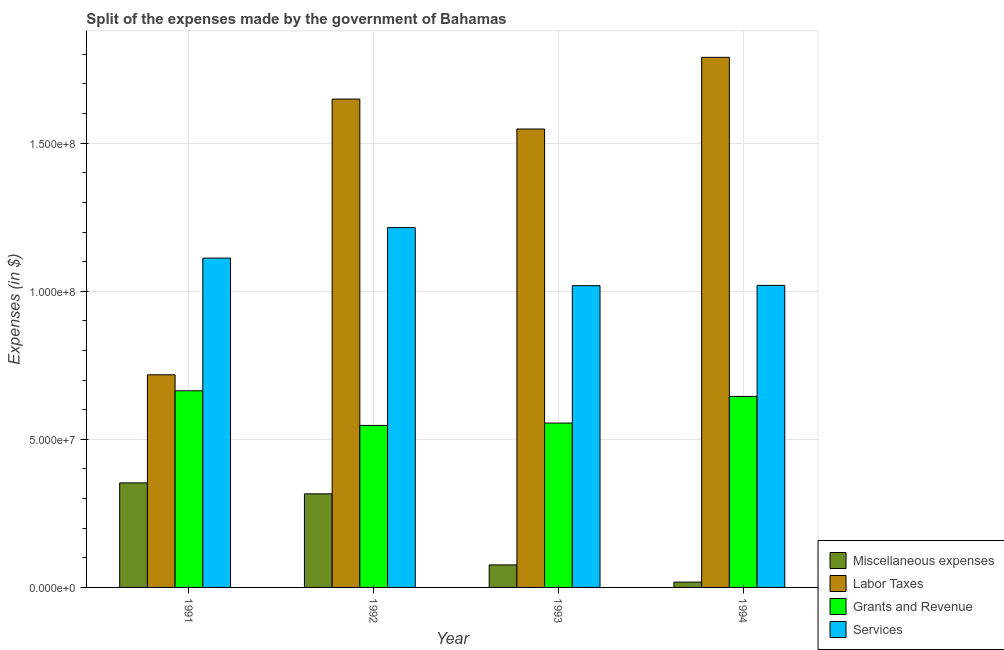How many different coloured bars are there?
Offer a terse response. 4. How many groups of bars are there?
Make the answer very short. 4. Are the number of bars on each tick of the X-axis equal?
Provide a short and direct response. Yes. What is the label of the 1st group of bars from the left?
Make the answer very short. 1991. What is the amount spent on labor taxes in 1991?
Offer a very short reply. 7.18e+07. Across all years, what is the maximum amount spent on miscellaneous expenses?
Your answer should be very brief. 3.53e+07. Across all years, what is the minimum amount spent on miscellaneous expenses?
Ensure brevity in your answer.  1.80e+06. In which year was the amount spent on labor taxes minimum?
Provide a succinct answer. 1991. What is the total amount spent on grants and revenue in the graph?
Offer a terse response. 2.41e+08. What is the difference between the amount spent on labor taxes in 1991 and that in 1994?
Offer a very short reply. -1.07e+08. What is the difference between the amount spent on services in 1993 and the amount spent on labor taxes in 1991?
Provide a short and direct response. -9.30e+06. What is the average amount spent on services per year?
Ensure brevity in your answer.  1.09e+08. In how many years, is the amount spent on grants and revenue greater than 40000000 $?
Keep it short and to the point. 4. What is the ratio of the amount spent on miscellaneous expenses in 1992 to that in 1994?
Give a very brief answer. 17.56. Is the difference between the amount spent on labor taxes in 1992 and 1994 greater than the difference between the amount spent on services in 1992 and 1994?
Keep it short and to the point. No. What is the difference between the highest and the second highest amount spent on grants and revenue?
Your answer should be very brief. 1.90e+06. What is the difference between the highest and the lowest amount spent on labor taxes?
Make the answer very short. 1.07e+08. Is the sum of the amount spent on grants and revenue in 1991 and 1994 greater than the maximum amount spent on services across all years?
Keep it short and to the point. Yes. Is it the case that in every year, the sum of the amount spent on labor taxes and amount spent on miscellaneous expenses is greater than the sum of amount spent on services and amount spent on grants and revenue?
Make the answer very short. No. What does the 4th bar from the left in 1992 represents?
Your response must be concise. Services. What does the 2nd bar from the right in 1991 represents?
Provide a short and direct response. Grants and Revenue. How many years are there in the graph?
Offer a very short reply. 4. What is the difference between two consecutive major ticks on the Y-axis?
Offer a very short reply. 5.00e+07. Does the graph contain grids?
Ensure brevity in your answer.  Yes. Where does the legend appear in the graph?
Your answer should be very brief. Bottom right. How are the legend labels stacked?
Your answer should be compact. Vertical. What is the title of the graph?
Make the answer very short. Split of the expenses made by the government of Bahamas. Does "UNPBF" appear as one of the legend labels in the graph?
Provide a succinct answer. No. What is the label or title of the X-axis?
Your answer should be compact. Year. What is the label or title of the Y-axis?
Your response must be concise. Expenses (in $). What is the Expenses (in $) in Miscellaneous expenses in 1991?
Your response must be concise. 3.53e+07. What is the Expenses (in $) in Labor Taxes in 1991?
Ensure brevity in your answer.  7.18e+07. What is the Expenses (in $) of Grants and Revenue in 1991?
Offer a terse response. 6.64e+07. What is the Expenses (in $) in Services in 1991?
Your response must be concise. 1.11e+08. What is the Expenses (in $) in Miscellaneous expenses in 1992?
Offer a terse response. 3.16e+07. What is the Expenses (in $) in Labor Taxes in 1992?
Offer a very short reply. 1.65e+08. What is the Expenses (in $) of Grants and Revenue in 1992?
Your response must be concise. 5.47e+07. What is the Expenses (in $) in Services in 1992?
Your answer should be very brief. 1.22e+08. What is the Expenses (in $) of Miscellaneous expenses in 1993?
Provide a succinct answer. 7.60e+06. What is the Expenses (in $) of Labor Taxes in 1993?
Provide a short and direct response. 1.55e+08. What is the Expenses (in $) of Grants and Revenue in 1993?
Offer a terse response. 5.55e+07. What is the Expenses (in $) in Services in 1993?
Ensure brevity in your answer.  1.02e+08. What is the Expenses (in $) in Miscellaneous expenses in 1994?
Offer a very short reply. 1.80e+06. What is the Expenses (in $) of Labor Taxes in 1994?
Your response must be concise. 1.79e+08. What is the Expenses (in $) in Grants and Revenue in 1994?
Ensure brevity in your answer.  6.45e+07. What is the Expenses (in $) of Services in 1994?
Ensure brevity in your answer.  1.02e+08. Across all years, what is the maximum Expenses (in $) in Miscellaneous expenses?
Keep it short and to the point. 3.53e+07. Across all years, what is the maximum Expenses (in $) in Labor Taxes?
Give a very brief answer. 1.79e+08. Across all years, what is the maximum Expenses (in $) in Grants and Revenue?
Give a very brief answer. 6.64e+07. Across all years, what is the maximum Expenses (in $) of Services?
Offer a very short reply. 1.22e+08. Across all years, what is the minimum Expenses (in $) in Miscellaneous expenses?
Offer a terse response. 1.80e+06. Across all years, what is the minimum Expenses (in $) in Labor Taxes?
Your response must be concise. 7.18e+07. Across all years, what is the minimum Expenses (in $) of Grants and Revenue?
Your answer should be very brief. 5.47e+07. Across all years, what is the minimum Expenses (in $) of Services?
Your response must be concise. 1.02e+08. What is the total Expenses (in $) in Miscellaneous expenses in the graph?
Your answer should be compact. 7.63e+07. What is the total Expenses (in $) of Labor Taxes in the graph?
Make the answer very short. 5.70e+08. What is the total Expenses (in $) in Grants and Revenue in the graph?
Make the answer very short. 2.41e+08. What is the total Expenses (in $) of Services in the graph?
Provide a short and direct response. 4.37e+08. What is the difference between the Expenses (in $) of Miscellaneous expenses in 1991 and that in 1992?
Your response must be concise. 3.70e+06. What is the difference between the Expenses (in $) of Labor Taxes in 1991 and that in 1992?
Your answer should be compact. -9.31e+07. What is the difference between the Expenses (in $) of Grants and Revenue in 1991 and that in 1992?
Your answer should be compact. 1.17e+07. What is the difference between the Expenses (in $) in Services in 1991 and that in 1992?
Make the answer very short. -1.03e+07. What is the difference between the Expenses (in $) of Miscellaneous expenses in 1991 and that in 1993?
Make the answer very short. 2.77e+07. What is the difference between the Expenses (in $) in Labor Taxes in 1991 and that in 1993?
Provide a succinct answer. -8.30e+07. What is the difference between the Expenses (in $) of Grants and Revenue in 1991 and that in 1993?
Provide a short and direct response. 1.09e+07. What is the difference between the Expenses (in $) in Services in 1991 and that in 1993?
Keep it short and to the point. 9.30e+06. What is the difference between the Expenses (in $) in Miscellaneous expenses in 1991 and that in 1994?
Give a very brief answer. 3.35e+07. What is the difference between the Expenses (in $) of Labor Taxes in 1991 and that in 1994?
Offer a very short reply. -1.07e+08. What is the difference between the Expenses (in $) of Grants and Revenue in 1991 and that in 1994?
Your response must be concise. 1.90e+06. What is the difference between the Expenses (in $) of Services in 1991 and that in 1994?
Ensure brevity in your answer.  9.20e+06. What is the difference between the Expenses (in $) of Miscellaneous expenses in 1992 and that in 1993?
Your answer should be compact. 2.40e+07. What is the difference between the Expenses (in $) of Labor Taxes in 1992 and that in 1993?
Ensure brevity in your answer.  1.01e+07. What is the difference between the Expenses (in $) in Grants and Revenue in 1992 and that in 1993?
Your response must be concise. -8.00e+05. What is the difference between the Expenses (in $) in Services in 1992 and that in 1993?
Provide a short and direct response. 1.96e+07. What is the difference between the Expenses (in $) of Miscellaneous expenses in 1992 and that in 1994?
Your answer should be compact. 2.98e+07. What is the difference between the Expenses (in $) in Labor Taxes in 1992 and that in 1994?
Your answer should be compact. -1.41e+07. What is the difference between the Expenses (in $) of Grants and Revenue in 1992 and that in 1994?
Offer a terse response. -9.80e+06. What is the difference between the Expenses (in $) in Services in 1992 and that in 1994?
Make the answer very short. 1.95e+07. What is the difference between the Expenses (in $) in Miscellaneous expenses in 1993 and that in 1994?
Your response must be concise. 5.80e+06. What is the difference between the Expenses (in $) in Labor Taxes in 1993 and that in 1994?
Provide a short and direct response. -2.42e+07. What is the difference between the Expenses (in $) in Grants and Revenue in 1993 and that in 1994?
Provide a succinct answer. -9.00e+06. What is the difference between the Expenses (in $) of Services in 1993 and that in 1994?
Provide a succinct answer. -1.00e+05. What is the difference between the Expenses (in $) of Miscellaneous expenses in 1991 and the Expenses (in $) of Labor Taxes in 1992?
Offer a very short reply. -1.30e+08. What is the difference between the Expenses (in $) of Miscellaneous expenses in 1991 and the Expenses (in $) of Grants and Revenue in 1992?
Provide a succinct answer. -1.94e+07. What is the difference between the Expenses (in $) of Miscellaneous expenses in 1991 and the Expenses (in $) of Services in 1992?
Give a very brief answer. -8.62e+07. What is the difference between the Expenses (in $) of Labor Taxes in 1991 and the Expenses (in $) of Grants and Revenue in 1992?
Offer a very short reply. 1.71e+07. What is the difference between the Expenses (in $) of Labor Taxes in 1991 and the Expenses (in $) of Services in 1992?
Offer a terse response. -4.97e+07. What is the difference between the Expenses (in $) of Grants and Revenue in 1991 and the Expenses (in $) of Services in 1992?
Offer a very short reply. -5.51e+07. What is the difference between the Expenses (in $) of Miscellaneous expenses in 1991 and the Expenses (in $) of Labor Taxes in 1993?
Offer a very short reply. -1.20e+08. What is the difference between the Expenses (in $) of Miscellaneous expenses in 1991 and the Expenses (in $) of Grants and Revenue in 1993?
Provide a short and direct response. -2.02e+07. What is the difference between the Expenses (in $) of Miscellaneous expenses in 1991 and the Expenses (in $) of Services in 1993?
Keep it short and to the point. -6.66e+07. What is the difference between the Expenses (in $) of Labor Taxes in 1991 and the Expenses (in $) of Grants and Revenue in 1993?
Keep it short and to the point. 1.63e+07. What is the difference between the Expenses (in $) of Labor Taxes in 1991 and the Expenses (in $) of Services in 1993?
Offer a very short reply. -3.01e+07. What is the difference between the Expenses (in $) in Grants and Revenue in 1991 and the Expenses (in $) in Services in 1993?
Keep it short and to the point. -3.55e+07. What is the difference between the Expenses (in $) in Miscellaneous expenses in 1991 and the Expenses (in $) in Labor Taxes in 1994?
Your response must be concise. -1.44e+08. What is the difference between the Expenses (in $) of Miscellaneous expenses in 1991 and the Expenses (in $) of Grants and Revenue in 1994?
Offer a terse response. -2.92e+07. What is the difference between the Expenses (in $) of Miscellaneous expenses in 1991 and the Expenses (in $) of Services in 1994?
Provide a short and direct response. -6.67e+07. What is the difference between the Expenses (in $) in Labor Taxes in 1991 and the Expenses (in $) in Grants and Revenue in 1994?
Make the answer very short. 7.30e+06. What is the difference between the Expenses (in $) in Labor Taxes in 1991 and the Expenses (in $) in Services in 1994?
Your answer should be very brief. -3.02e+07. What is the difference between the Expenses (in $) of Grants and Revenue in 1991 and the Expenses (in $) of Services in 1994?
Your answer should be compact. -3.56e+07. What is the difference between the Expenses (in $) of Miscellaneous expenses in 1992 and the Expenses (in $) of Labor Taxes in 1993?
Your answer should be compact. -1.23e+08. What is the difference between the Expenses (in $) of Miscellaneous expenses in 1992 and the Expenses (in $) of Grants and Revenue in 1993?
Your response must be concise. -2.39e+07. What is the difference between the Expenses (in $) in Miscellaneous expenses in 1992 and the Expenses (in $) in Services in 1993?
Your answer should be very brief. -7.03e+07. What is the difference between the Expenses (in $) in Labor Taxes in 1992 and the Expenses (in $) in Grants and Revenue in 1993?
Offer a very short reply. 1.09e+08. What is the difference between the Expenses (in $) in Labor Taxes in 1992 and the Expenses (in $) in Services in 1993?
Make the answer very short. 6.30e+07. What is the difference between the Expenses (in $) in Grants and Revenue in 1992 and the Expenses (in $) in Services in 1993?
Ensure brevity in your answer.  -4.72e+07. What is the difference between the Expenses (in $) in Miscellaneous expenses in 1992 and the Expenses (in $) in Labor Taxes in 1994?
Make the answer very short. -1.47e+08. What is the difference between the Expenses (in $) of Miscellaneous expenses in 1992 and the Expenses (in $) of Grants and Revenue in 1994?
Keep it short and to the point. -3.29e+07. What is the difference between the Expenses (in $) of Miscellaneous expenses in 1992 and the Expenses (in $) of Services in 1994?
Offer a terse response. -7.04e+07. What is the difference between the Expenses (in $) of Labor Taxes in 1992 and the Expenses (in $) of Grants and Revenue in 1994?
Provide a succinct answer. 1.00e+08. What is the difference between the Expenses (in $) of Labor Taxes in 1992 and the Expenses (in $) of Services in 1994?
Provide a succinct answer. 6.29e+07. What is the difference between the Expenses (in $) in Grants and Revenue in 1992 and the Expenses (in $) in Services in 1994?
Provide a short and direct response. -4.73e+07. What is the difference between the Expenses (in $) of Miscellaneous expenses in 1993 and the Expenses (in $) of Labor Taxes in 1994?
Keep it short and to the point. -1.71e+08. What is the difference between the Expenses (in $) of Miscellaneous expenses in 1993 and the Expenses (in $) of Grants and Revenue in 1994?
Provide a short and direct response. -5.69e+07. What is the difference between the Expenses (in $) of Miscellaneous expenses in 1993 and the Expenses (in $) of Services in 1994?
Ensure brevity in your answer.  -9.44e+07. What is the difference between the Expenses (in $) in Labor Taxes in 1993 and the Expenses (in $) in Grants and Revenue in 1994?
Provide a short and direct response. 9.03e+07. What is the difference between the Expenses (in $) of Labor Taxes in 1993 and the Expenses (in $) of Services in 1994?
Give a very brief answer. 5.28e+07. What is the difference between the Expenses (in $) in Grants and Revenue in 1993 and the Expenses (in $) in Services in 1994?
Offer a very short reply. -4.65e+07. What is the average Expenses (in $) in Miscellaneous expenses per year?
Make the answer very short. 1.91e+07. What is the average Expenses (in $) in Labor Taxes per year?
Offer a very short reply. 1.43e+08. What is the average Expenses (in $) in Grants and Revenue per year?
Make the answer very short. 6.03e+07. What is the average Expenses (in $) of Services per year?
Ensure brevity in your answer.  1.09e+08. In the year 1991, what is the difference between the Expenses (in $) of Miscellaneous expenses and Expenses (in $) of Labor Taxes?
Your answer should be compact. -3.65e+07. In the year 1991, what is the difference between the Expenses (in $) in Miscellaneous expenses and Expenses (in $) in Grants and Revenue?
Offer a terse response. -3.11e+07. In the year 1991, what is the difference between the Expenses (in $) of Miscellaneous expenses and Expenses (in $) of Services?
Provide a succinct answer. -7.59e+07. In the year 1991, what is the difference between the Expenses (in $) of Labor Taxes and Expenses (in $) of Grants and Revenue?
Your response must be concise. 5.40e+06. In the year 1991, what is the difference between the Expenses (in $) of Labor Taxes and Expenses (in $) of Services?
Offer a terse response. -3.94e+07. In the year 1991, what is the difference between the Expenses (in $) in Grants and Revenue and Expenses (in $) in Services?
Your response must be concise. -4.48e+07. In the year 1992, what is the difference between the Expenses (in $) of Miscellaneous expenses and Expenses (in $) of Labor Taxes?
Ensure brevity in your answer.  -1.33e+08. In the year 1992, what is the difference between the Expenses (in $) of Miscellaneous expenses and Expenses (in $) of Grants and Revenue?
Make the answer very short. -2.31e+07. In the year 1992, what is the difference between the Expenses (in $) in Miscellaneous expenses and Expenses (in $) in Services?
Provide a succinct answer. -8.99e+07. In the year 1992, what is the difference between the Expenses (in $) in Labor Taxes and Expenses (in $) in Grants and Revenue?
Provide a short and direct response. 1.10e+08. In the year 1992, what is the difference between the Expenses (in $) of Labor Taxes and Expenses (in $) of Services?
Keep it short and to the point. 4.34e+07. In the year 1992, what is the difference between the Expenses (in $) of Grants and Revenue and Expenses (in $) of Services?
Ensure brevity in your answer.  -6.68e+07. In the year 1993, what is the difference between the Expenses (in $) in Miscellaneous expenses and Expenses (in $) in Labor Taxes?
Give a very brief answer. -1.47e+08. In the year 1993, what is the difference between the Expenses (in $) in Miscellaneous expenses and Expenses (in $) in Grants and Revenue?
Your answer should be very brief. -4.79e+07. In the year 1993, what is the difference between the Expenses (in $) of Miscellaneous expenses and Expenses (in $) of Services?
Keep it short and to the point. -9.43e+07. In the year 1993, what is the difference between the Expenses (in $) in Labor Taxes and Expenses (in $) in Grants and Revenue?
Offer a terse response. 9.93e+07. In the year 1993, what is the difference between the Expenses (in $) of Labor Taxes and Expenses (in $) of Services?
Your answer should be compact. 5.29e+07. In the year 1993, what is the difference between the Expenses (in $) in Grants and Revenue and Expenses (in $) in Services?
Give a very brief answer. -4.64e+07. In the year 1994, what is the difference between the Expenses (in $) in Miscellaneous expenses and Expenses (in $) in Labor Taxes?
Provide a succinct answer. -1.77e+08. In the year 1994, what is the difference between the Expenses (in $) in Miscellaneous expenses and Expenses (in $) in Grants and Revenue?
Your answer should be compact. -6.27e+07. In the year 1994, what is the difference between the Expenses (in $) of Miscellaneous expenses and Expenses (in $) of Services?
Keep it short and to the point. -1.00e+08. In the year 1994, what is the difference between the Expenses (in $) in Labor Taxes and Expenses (in $) in Grants and Revenue?
Offer a very short reply. 1.14e+08. In the year 1994, what is the difference between the Expenses (in $) of Labor Taxes and Expenses (in $) of Services?
Your answer should be compact. 7.70e+07. In the year 1994, what is the difference between the Expenses (in $) of Grants and Revenue and Expenses (in $) of Services?
Ensure brevity in your answer.  -3.75e+07. What is the ratio of the Expenses (in $) of Miscellaneous expenses in 1991 to that in 1992?
Your answer should be compact. 1.12. What is the ratio of the Expenses (in $) of Labor Taxes in 1991 to that in 1992?
Your answer should be compact. 0.44. What is the ratio of the Expenses (in $) in Grants and Revenue in 1991 to that in 1992?
Offer a terse response. 1.21. What is the ratio of the Expenses (in $) of Services in 1991 to that in 1992?
Give a very brief answer. 0.92. What is the ratio of the Expenses (in $) of Miscellaneous expenses in 1991 to that in 1993?
Your response must be concise. 4.64. What is the ratio of the Expenses (in $) of Labor Taxes in 1991 to that in 1993?
Offer a very short reply. 0.46. What is the ratio of the Expenses (in $) of Grants and Revenue in 1991 to that in 1993?
Make the answer very short. 1.2. What is the ratio of the Expenses (in $) of Services in 1991 to that in 1993?
Make the answer very short. 1.09. What is the ratio of the Expenses (in $) in Miscellaneous expenses in 1991 to that in 1994?
Your answer should be very brief. 19.61. What is the ratio of the Expenses (in $) in Labor Taxes in 1991 to that in 1994?
Provide a succinct answer. 0.4. What is the ratio of the Expenses (in $) of Grants and Revenue in 1991 to that in 1994?
Offer a very short reply. 1.03. What is the ratio of the Expenses (in $) of Services in 1991 to that in 1994?
Your answer should be very brief. 1.09. What is the ratio of the Expenses (in $) of Miscellaneous expenses in 1992 to that in 1993?
Give a very brief answer. 4.16. What is the ratio of the Expenses (in $) in Labor Taxes in 1992 to that in 1993?
Ensure brevity in your answer.  1.07. What is the ratio of the Expenses (in $) in Grants and Revenue in 1992 to that in 1993?
Your response must be concise. 0.99. What is the ratio of the Expenses (in $) of Services in 1992 to that in 1993?
Give a very brief answer. 1.19. What is the ratio of the Expenses (in $) in Miscellaneous expenses in 1992 to that in 1994?
Offer a terse response. 17.56. What is the ratio of the Expenses (in $) of Labor Taxes in 1992 to that in 1994?
Your answer should be compact. 0.92. What is the ratio of the Expenses (in $) in Grants and Revenue in 1992 to that in 1994?
Your response must be concise. 0.85. What is the ratio of the Expenses (in $) of Services in 1992 to that in 1994?
Provide a short and direct response. 1.19. What is the ratio of the Expenses (in $) in Miscellaneous expenses in 1993 to that in 1994?
Make the answer very short. 4.22. What is the ratio of the Expenses (in $) in Labor Taxes in 1993 to that in 1994?
Your answer should be compact. 0.86. What is the ratio of the Expenses (in $) of Grants and Revenue in 1993 to that in 1994?
Your answer should be compact. 0.86. What is the ratio of the Expenses (in $) of Services in 1993 to that in 1994?
Your response must be concise. 1. What is the difference between the highest and the second highest Expenses (in $) in Miscellaneous expenses?
Ensure brevity in your answer.  3.70e+06. What is the difference between the highest and the second highest Expenses (in $) in Labor Taxes?
Make the answer very short. 1.41e+07. What is the difference between the highest and the second highest Expenses (in $) of Grants and Revenue?
Offer a terse response. 1.90e+06. What is the difference between the highest and the second highest Expenses (in $) of Services?
Provide a short and direct response. 1.03e+07. What is the difference between the highest and the lowest Expenses (in $) in Miscellaneous expenses?
Offer a very short reply. 3.35e+07. What is the difference between the highest and the lowest Expenses (in $) in Labor Taxes?
Provide a short and direct response. 1.07e+08. What is the difference between the highest and the lowest Expenses (in $) in Grants and Revenue?
Your response must be concise. 1.17e+07. What is the difference between the highest and the lowest Expenses (in $) of Services?
Offer a very short reply. 1.96e+07. 